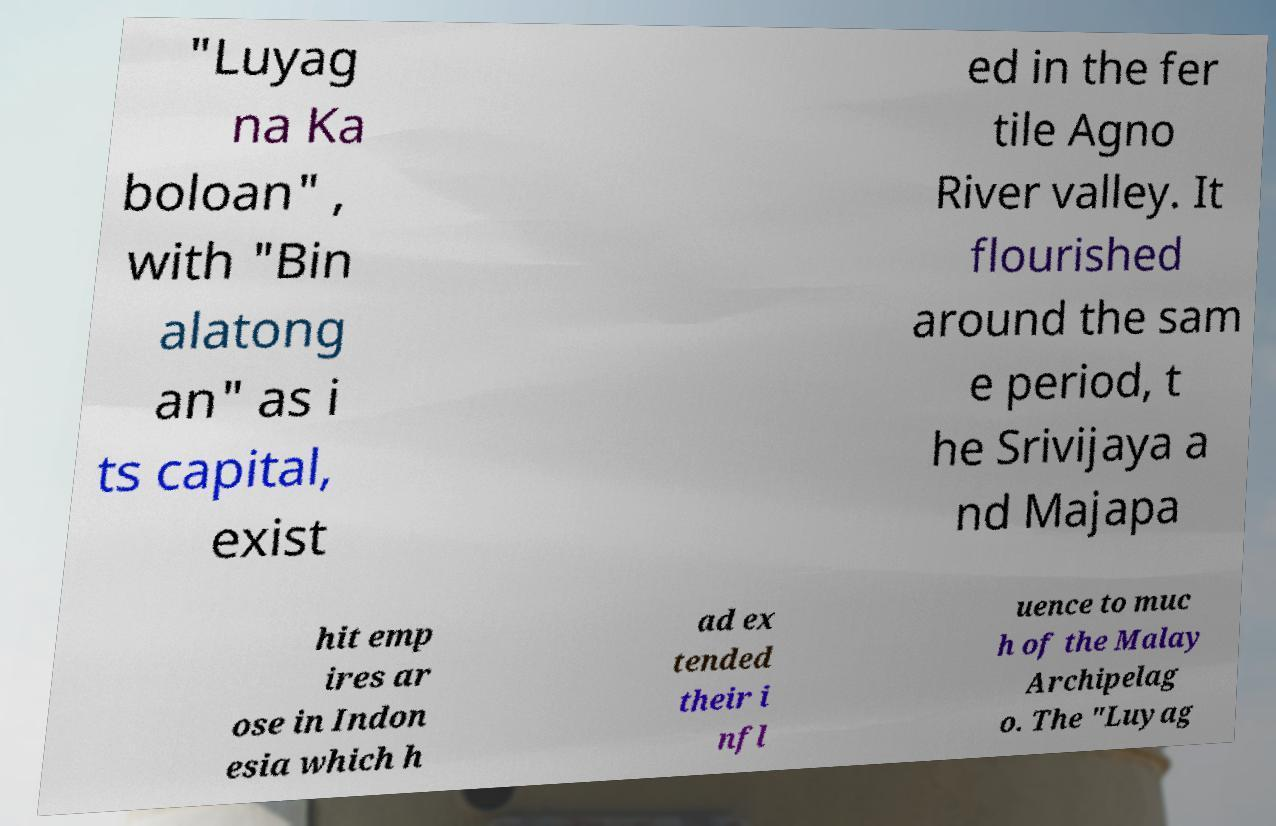Can you accurately transcribe the text from the provided image for me? "Luyag na Ka boloan" , with "Bin alatong an" as i ts capital, exist ed in the fer tile Agno River valley. It flourished around the sam e period, t he Srivijaya a nd Majapa hit emp ires ar ose in Indon esia which h ad ex tended their i nfl uence to muc h of the Malay Archipelag o. The "Luyag 